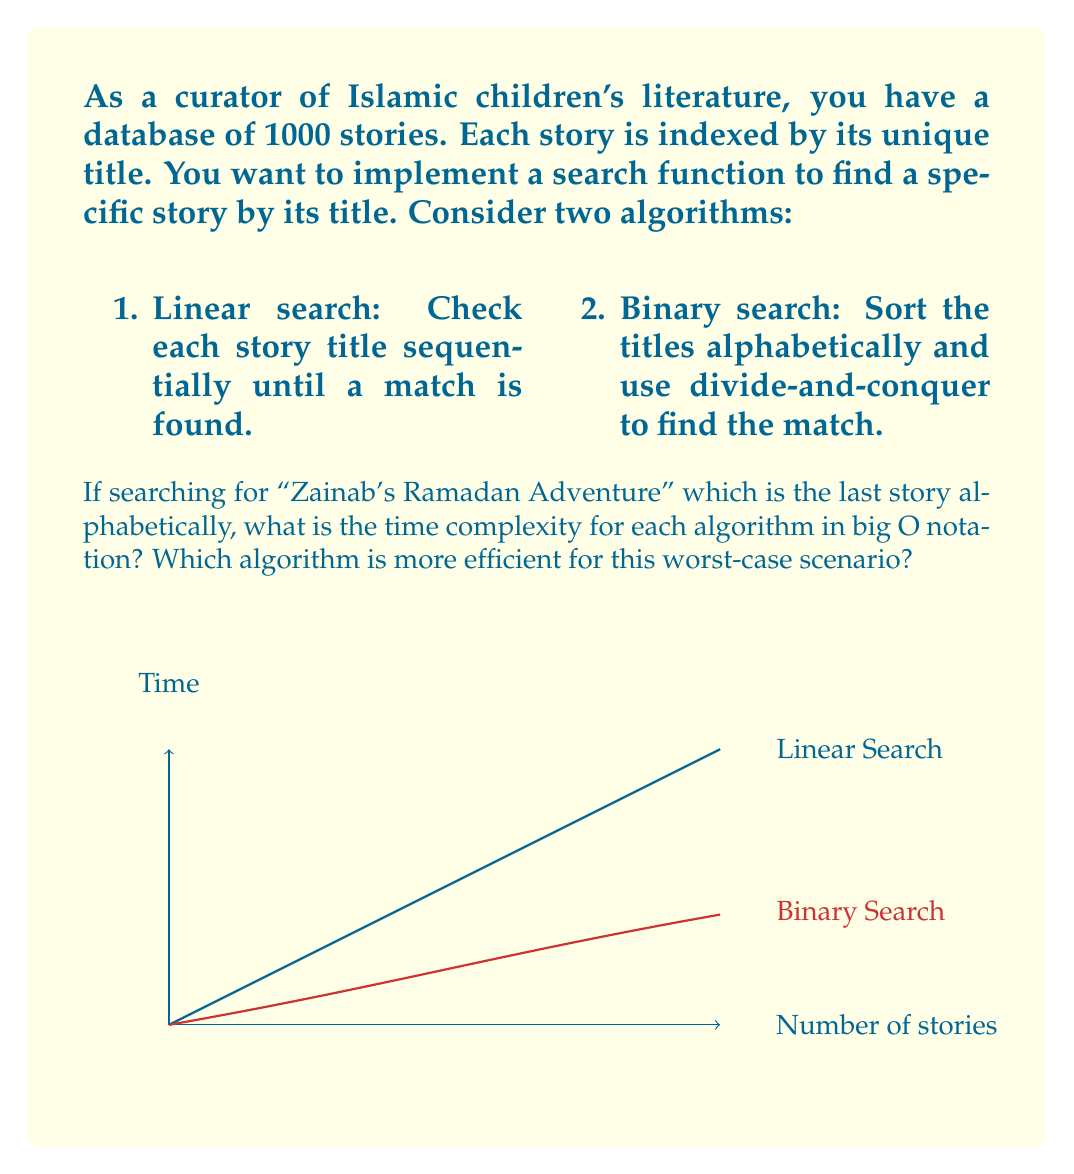Can you answer this question? Let's analyze both algorithms step by step:

1. Linear Search:
   - In the worst case (searching for the last story), we need to check all 1000 stories.
   - The time complexity is directly proportional to the number of stories (n).
   - Time complexity: $O(n)$, where $n = 1000$

2. Binary Search:
   - First, we need to sort the titles, which takes $O(n \log n)$ time.
   - Once sorted, binary search repeatedly divides the search interval in half.
   - The number of comparisons is at most $\log_2 n$.
   - Time complexity for searching: $O(\log n)$

   Total time complexity: $O(n \log n + \log n) = O(n \log n)$

For the worst-case scenario (searching for "Zainab's Ramadan Adventure"):

- Linear Search: $O(n) = O(1000)$
- Binary Search: $O(n \log n) = O(1000 \log 1000) \approx O(9966)$

Although the binary search looks worse in big O notation, it's important to note:

1. The sorting is a one-time operation. If we search multiple times in the same sorted database, we only need $O(\log n)$ for each subsequent search.

2. For large datasets, binary search becomes more efficient. The crossover point where binary search outperforms linear search depends on the specific implementation and hardware.

In this specific case with 1000 stories, linear search might be faster for a single search operation due to its simplicity and the overhead of sorting for binary search. However, if multiple searches are performed on the same dataset, binary search would be more efficient in the long run.
Answer: Linear Search: $O(n)$, Binary Search: $O(n \log n)$. For a single search in this case, Linear Search is more efficient. 